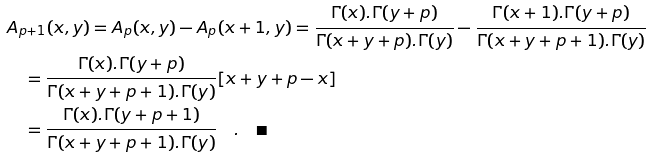Convert formula to latex. <formula><loc_0><loc_0><loc_500><loc_500>& A _ { p + 1 } ( x , y ) = A _ { p } ( x , y ) - A _ { p } ( x + 1 , y ) = \frac { \Gamma ( x ) . \Gamma ( y + p ) } { \Gamma ( x + y + p ) . \Gamma ( y ) } - \frac { \Gamma ( x + 1 ) . \Gamma ( y + p ) } { \Gamma ( x + y + p + 1 ) . \Gamma ( y ) } \\ & \quad = \frac { \Gamma ( x ) . \Gamma ( y + p ) } { \Gamma ( x + y + p + 1 ) . \Gamma ( y ) } [ x + y + p - x ] \\ & \quad = \frac { \Gamma ( x ) . \Gamma ( y + p + 1 ) } { \Gamma ( x + y + p + 1 ) . \Gamma ( y ) } \quad . \quad \blacksquare</formula> 